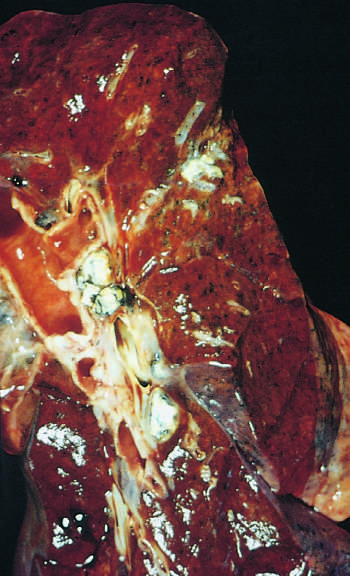re two helical spirochetes seen left?
Answer the question using a single word or phrase. No 